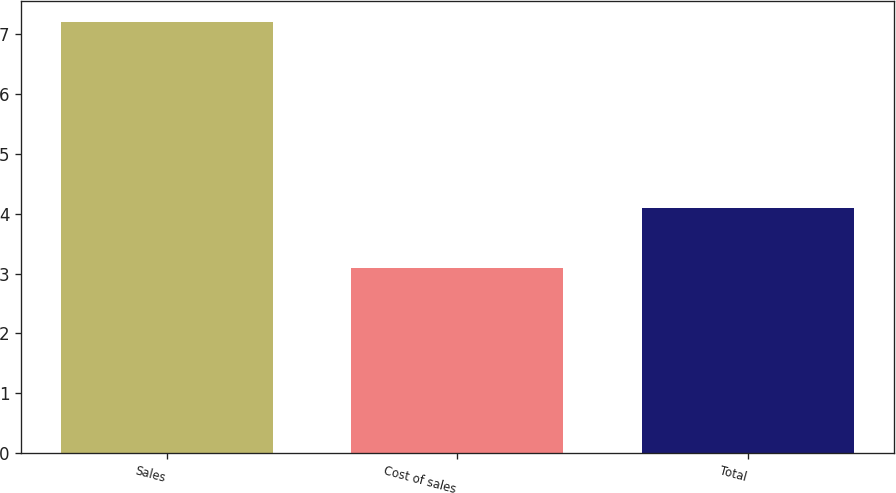Convert chart. <chart><loc_0><loc_0><loc_500><loc_500><bar_chart><fcel>Sales<fcel>Cost of sales<fcel>Total<nl><fcel>7.2<fcel>3.1<fcel>4.1<nl></chart> 